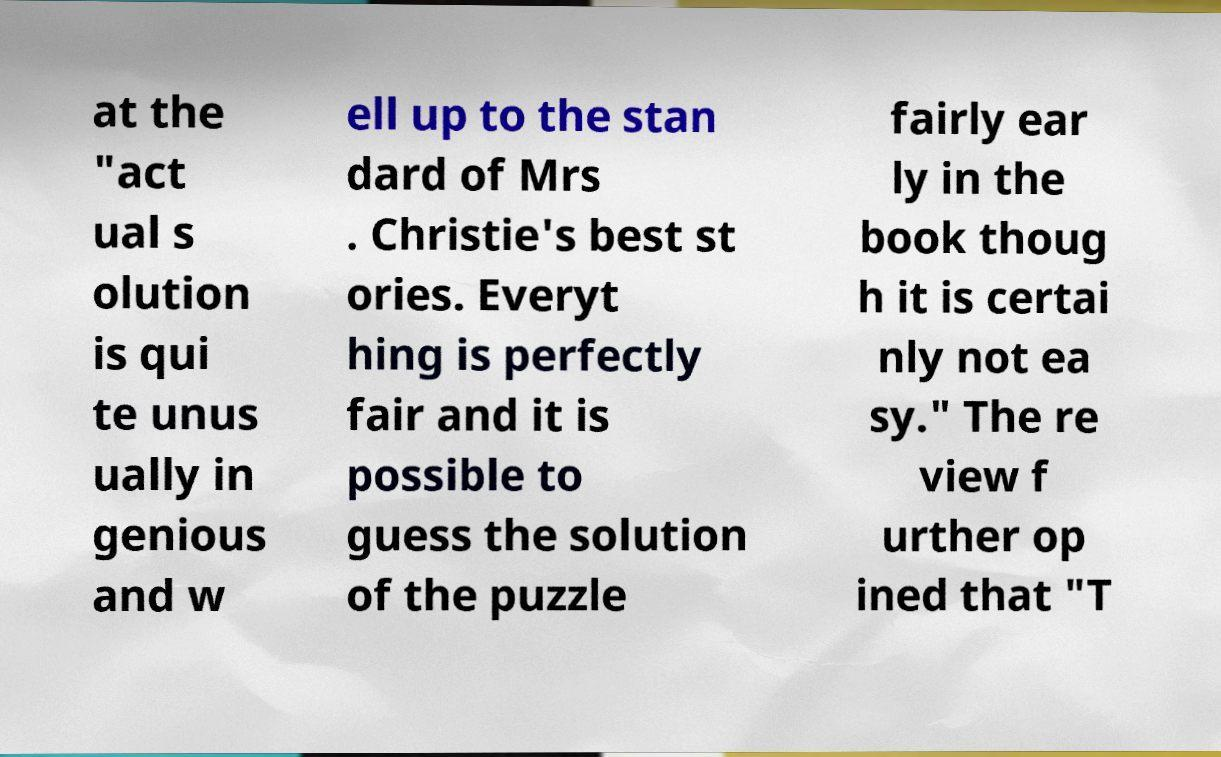Please identify and transcribe the text found in this image. at the "act ual s olution is qui te unus ually in genious and w ell up to the stan dard of Mrs . Christie's best st ories. Everyt hing is perfectly fair and it is possible to guess the solution of the puzzle fairly ear ly in the book thoug h it is certai nly not ea sy." The re view f urther op ined that "T 